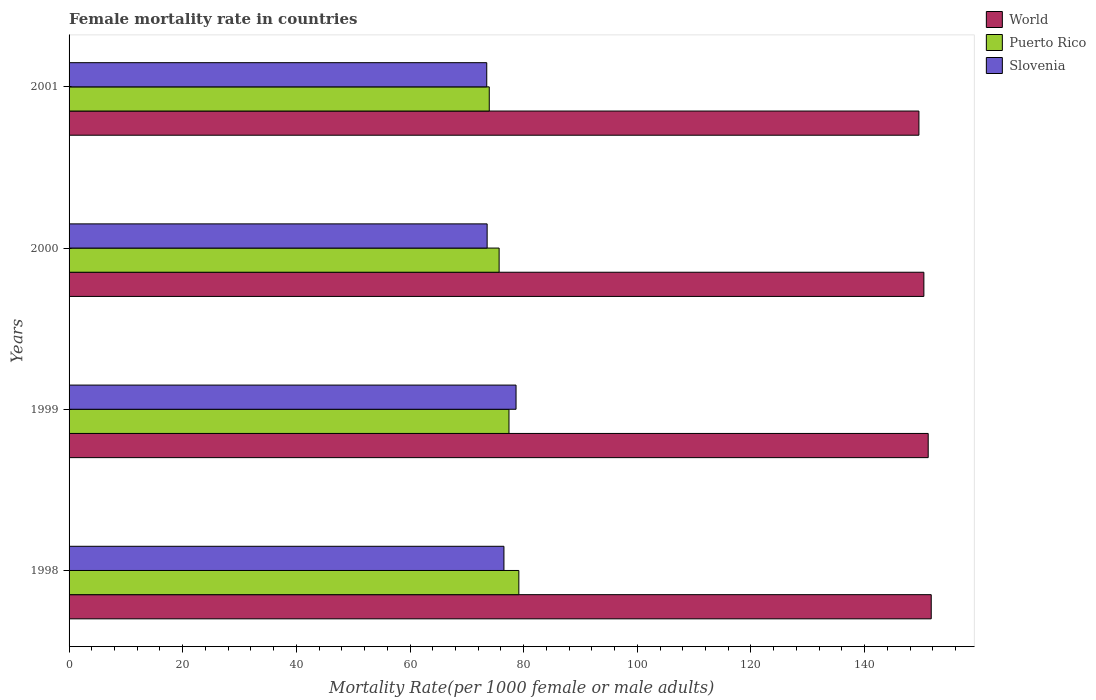How many groups of bars are there?
Your answer should be compact. 4. How many bars are there on the 3rd tick from the bottom?
Your answer should be very brief. 3. In how many cases, is the number of bars for a given year not equal to the number of legend labels?
Give a very brief answer. 0. What is the female mortality rate in World in 2001?
Provide a succinct answer. 149.55. Across all years, what is the maximum female mortality rate in Slovenia?
Offer a very short reply. 78.66. Across all years, what is the minimum female mortality rate in Puerto Rico?
Provide a succinct answer. 73.94. In which year was the female mortality rate in Puerto Rico maximum?
Give a very brief answer. 1998. What is the total female mortality rate in Slovenia in the graph?
Offer a terse response. 302.26. What is the difference between the female mortality rate in Puerto Rico in 1998 and that in 2000?
Ensure brevity in your answer.  3.47. What is the difference between the female mortality rate in Puerto Rico in 2000 and the female mortality rate in Slovenia in 1999?
Offer a very short reply. -2.98. What is the average female mortality rate in Slovenia per year?
Provide a succinct answer. 75.56. In the year 1998, what is the difference between the female mortality rate in Puerto Rico and female mortality rate in World?
Make the answer very short. -72.57. In how many years, is the female mortality rate in World greater than 108 ?
Your answer should be compact. 4. What is the ratio of the female mortality rate in Puerto Rico in 2000 to that in 2001?
Make the answer very short. 1.02. Is the female mortality rate in Puerto Rico in 1998 less than that in 2000?
Keep it short and to the point. No. What is the difference between the highest and the second highest female mortality rate in World?
Keep it short and to the point. 0.53. What is the difference between the highest and the lowest female mortality rate in World?
Provide a succinct answer. 2.17. Is the sum of the female mortality rate in Slovenia in 1998 and 2001 greater than the maximum female mortality rate in World across all years?
Keep it short and to the point. No. What does the 3rd bar from the top in 2000 represents?
Your answer should be compact. World. What does the 1st bar from the bottom in 2000 represents?
Offer a terse response. World. Is it the case that in every year, the sum of the female mortality rate in Puerto Rico and female mortality rate in World is greater than the female mortality rate in Slovenia?
Give a very brief answer. Yes. How many bars are there?
Provide a succinct answer. 12. Are all the bars in the graph horizontal?
Provide a succinct answer. Yes. What is the difference between two consecutive major ticks on the X-axis?
Make the answer very short. 20. Are the values on the major ticks of X-axis written in scientific E-notation?
Offer a very short reply. No. How many legend labels are there?
Provide a short and direct response. 3. What is the title of the graph?
Your answer should be very brief. Female mortality rate in countries. Does "El Salvador" appear as one of the legend labels in the graph?
Offer a very short reply. No. What is the label or title of the X-axis?
Provide a short and direct response. Mortality Rate(per 1000 female or male adults). What is the label or title of the Y-axis?
Make the answer very short. Years. What is the Mortality Rate(per 1000 female or male adults) in World in 1998?
Offer a very short reply. 151.72. What is the Mortality Rate(per 1000 female or male adults) of Puerto Rico in 1998?
Your answer should be very brief. 79.15. What is the Mortality Rate(per 1000 female or male adults) in Slovenia in 1998?
Provide a succinct answer. 76.53. What is the Mortality Rate(per 1000 female or male adults) in World in 1999?
Your answer should be compact. 151.19. What is the Mortality Rate(per 1000 female or male adults) in Puerto Rico in 1999?
Your answer should be very brief. 77.42. What is the Mortality Rate(per 1000 female or male adults) of Slovenia in 1999?
Provide a short and direct response. 78.66. What is the Mortality Rate(per 1000 female or male adults) of World in 2000?
Give a very brief answer. 150.43. What is the Mortality Rate(per 1000 female or male adults) of Puerto Rico in 2000?
Make the answer very short. 75.68. What is the Mortality Rate(per 1000 female or male adults) of Slovenia in 2000?
Provide a short and direct response. 73.57. What is the Mortality Rate(per 1000 female or male adults) in World in 2001?
Provide a succinct answer. 149.55. What is the Mortality Rate(per 1000 female or male adults) of Puerto Rico in 2001?
Ensure brevity in your answer.  73.94. What is the Mortality Rate(per 1000 female or male adults) in Slovenia in 2001?
Offer a terse response. 73.5. Across all years, what is the maximum Mortality Rate(per 1000 female or male adults) of World?
Your response must be concise. 151.72. Across all years, what is the maximum Mortality Rate(per 1000 female or male adults) in Puerto Rico?
Offer a very short reply. 79.15. Across all years, what is the maximum Mortality Rate(per 1000 female or male adults) in Slovenia?
Keep it short and to the point. 78.66. Across all years, what is the minimum Mortality Rate(per 1000 female or male adults) in World?
Your answer should be compact. 149.55. Across all years, what is the minimum Mortality Rate(per 1000 female or male adults) of Puerto Rico?
Ensure brevity in your answer.  73.94. Across all years, what is the minimum Mortality Rate(per 1000 female or male adults) of Slovenia?
Provide a succinct answer. 73.5. What is the total Mortality Rate(per 1000 female or male adults) in World in the graph?
Offer a terse response. 602.89. What is the total Mortality Rate(per 1000 female or male adults) of Puerto Rico in the graph?
Give a very brief answer. 306.19. What is the total Mortality Rate(per 1000 female or male adults) of Slovenia in the graph?
Provide a succinct answer. 302.26. What is the difference between the Mortality Rate(per 1000 female or male adults) in World in 1998 and that in 1999?
Provide a short and direct response. 0.53. What is the difference between the Mortality Rate(per 1000 female or male adults) in Puerto Rico in 1998 and that in 1999?
Provide a succinct answer. 1.74. What is the difference between the Mortality Rate(per 1000 female or male adults) in Slovenia in 1998 and that in 1999?
Your answer should be compact. -2.13. What is the difference between the Mortality Rate(per 1000 female or male adults) of World in 1998 and that in 2000?
Keep it short and to the point. 1.29. What is the difference between the Mortality Rate(per 1000 female or male adults) of Puerto Rico in 1998 and that in 2000?
Your answer should be compact. 3.47. What is the difference between the Mortality Rate(per 1000 female or male adults) in Slovenia in 1998 and that in 2000?
Keep it short and to the point. 2.96. What is the difference between the Mortality Rate(per 1000 female or male adults) in World in 1998 and that in 2001?
Provide a succinct answer. 2.17. What is the difference between the Mortality Rate(per 1000 female or male adults) in Puerto Rico in 1998 and that in 2001?
Make the answer very short. 5.21. What is the difference between the Mortality Rate(per 1000 female or male adults) of Slovenia in 1998 and that in 2001?
Offer a terse response. 3.02. What is the difference between the Mortality Rate(per 1000 female or male adults) of World in 1999 and that in 2000?
Your answer should be very brief. 0.76. What is the difference between the Mortality Rate(per 1000 female or male adults) of Puerto Rico in 1999 and that in 2000?
Make the answer very short. 1.74. What is the difference between the Mortality Rate(per 1000 female or male adults) of Slovenia in 1999 and that in 2000?
Ensure brevity in your answer.  5.09. What is the difference between the Mortality Rate(per 1000 female or male adults) of World in 1999 and that in 2001?
Offer a terse response. 1.63. What is the difference between the Mortality Rate(per 1000 female or male adults) of Puerto Rico in 1999 and that in 2001?
Give a very brief answer. 3.47. What is the difference between the Mortality Rate(per 1000 female or male adults) in Slovenia in 1999 and that in 2001?
Keep it short and to the point. 5.16. What is the difference between the Mortality Rate(per 1000 female or male adults) in World in 2000 and that in 2001?
Keep it short and to the point. 0.87. What is the difference between the Mortality Rate(per 1000 female or male adults) of Puerto Rico in 2000 and that in 2001?
Offer a terse response. 1.74. What is the difference between the Mortality Rate(per 1000 female or male adults) in Slovenia in 2000 and that in 2001?
Give a very brief answer. 0.07. What is the difference between the Mortality Rate(per 1000 female or male adults) of World in 1998 and the Mortality Rate(per 1000 female or male adults) of Puerto Rico in 1999?
Provide a short and direct response. 74.31. What is the difference between the Mortality Rate(per 1000 female or male adults) in World in 1998 and the Mortality Rate(per 1000 female or male adults) in Slovenia in 1999?
Your response must be concise. 73.06. What is the difference between the Mortality Rate(per 1000 female or male adults) of Puerto Rico in 1998 and the Mortality Rate(per 1000 female or male adults) of Slovenia in 1999?
Your answer should be compact. 0.49. What is the difference between the Mortality Rate(per 1000 female or male adults) of World in 1998 and the Mortality Rate(per 1000 female or male adults) of Puerto Rico in 2000?
Keep it short and to the point. 76.04. What is the difference between the Mortality Rate(per 1000 female or male adults) of World in 1998 and the Mortality Rate(per 1000 female or male adults) of Slovenia in 2000?
Provide a succinct answer. 78.15. What is the difference between the Mortality Rate(per 1000 female or male adults) of Puerto Rico in 1998 and the Mortality Rate(per 1000 female or male adults) of Slovenia in 2000?
Keep it short and to the point. 5.58. What is the difference between the Mortality Rate(per 1000 female or male adults) of World in 1998 and the Mortality Rate(per 1000 female or male adults) of Puerto Rico in 2001?
Provide a succinct answer. 77.78. What is the difference between the Mortality Rate(per 1000 female or male adults) in World in 1998 and the Mortality Rate(per 1000 female or male adults) in Slovenia in 2001?
Give a very brief answer. 78.22. What is the difference between the Mortality Rate(per 1000 female or male adults) in Puerto Rico in 1998 and the Mortality Rate(per 1000 female or male adults) in Slovenia in 2001?
Give a very brief answer. 5.65. What is the difference between the Mortality Rate(per 1000 female or male adults) of World in 1999 and the Mortality Rate(per 1000 female or male adults) of Puerto Rico in 2000?
Provide a succinct answer. 75.51. What is the difference between the Mortality Rate(per 1000 female or male adults) of World in 1999 and the Mortality Rate(per 1000 female or male adults) of Slovenia in 2000?
Offer a very short reply. 77.62. What is the difference between the Mortality Rate(per 1000 female or male adults) of Puerto Rico in 1999 and the Mortality Rate(per 1000 female or male adults) of Slovenia in 2000?
Offer a terse response. 3.84. What is the difference between the Mortality Rate(per 1000 female or male adults) in World in 1999 and the Mortality Rate(per 1000 female or male adults) in Puerto Rico in 2001?
Offer a very short reply. 77.24. What is the difference between the Mortality Rate(per 1000 female or male adults) in World in 1999 and the Mortality Rate(per 1000 female or male adults) in Slovenia in 2001?
Your answer should be very brief. 77.69. What is the difference between the Mortality Rate(per 1000 female or male adults) of Puerto Rico in 1999 and the Mortality Rate(per 1000 female or male adults) of Slovenia in 2001?
Your answer should be very brief. 3.91. What is the difference between the Mortality Rate(per 1000 female or male adults) in World in 2000 and the Mortality Rate(per 1000 female or male adults) in Puerto Rico in 2001?
Keep it short and to the point. 76.48. What is the difference between the Mortality Rate(per 1000 female or male adults) of World in 2000 and the Mortality Rate(per 1000 female or male adults) of Slovenia in 2001?
Make the answer very short. 76.92. What is the difference between the Mortality Rate(per 1000 female or male adults) in Puerto Rico in 2000 and the Mortality Rate(per 1000 female or male adults) in Slovenia in 2001?
Make the answer very short. 2.18. What is the average Mortality Rate(per 1000 female or male adults) in World per year?
Keep it short and to the point. 150.72. What is the average Mortality Rate(per 1000 female or male adults) of Puerto Rico per year?
Give a very brief answer. 76.55. What is the average Mortality Rate(per 1000 female or male adults) in Slovenia per year?
Make the answer very short. 75.56. In the year 1998, what is the difference between the Mortality Rate(per 1000 female or male adults) in World and Mortality Rate(per 1000 female or male adults) in Puerto Rico?
Your answer should be compact. 72.57. In the year 1998, what is the difference between the Mortality Rate(per 1000 female or male adults) of World and Mortality Rate(per 1000 female or male adults) of Slovenia?
Give a very brief answer. 75.19. In the year 1998, what is the difference between the Mortality Rate(per 1000 female or male adults) in Puerto Rico and Mortality Rate(per 1000 female or male adults) in Slovenia?
Give a very brief answer. 2.62. In the year 1999, what is the difference between the Mortality Rate(per 1000 female or male adults) of World and Mortality Rate(per 1000 female or male adults) of Puerto Rico?
Ensure brevity in your answer.  73.77. In the year 1999, what is the difference between the Mortality Rate(per 1000 female or male adults) of World and Mortality Rate(per 1000 female or male adults) of Slovenia?
Offer a very short reply. 72.53. In the year 1999, what is the difference between the Mortality Rate(per 1000 female or male adults) in Puerto Rico and Mortality Rate(per 1000 female or male adults) in Slovenia?
Provide a short and direct response. -1.24. In the year 2000, what is the difference between the Mortality Rate(per 1000 female or male adults) of World and Mortality Rate(per 1000 female or male adults) of Puerto Rico?
Make the answer very short. 74.75. In the year 2000, what is the difference between the Mortality Rate(per 1000 female or male adults) of World and Mortality Rate(per 1000 female or male adults) of Slovenia?
Provide a short and direct response. 76.85. In the year 2000, what is the difference between the Mortality Rate(per 1000 female or male adults) in Puerto Rico and Mortality Rate(per 1000 female or male adults) in Slovenia?
Your answer should be compact. 2.11. In the year 2001, what is the difference between the Mortality Rate(per 1000 female or male adults) in World and Mortality Rate(per 1000 female or male adults) in Puerto Rico?
Provide a succinct answer. 75.61. In the year 2001, what is the difference between the Mortality Rate(per 1000 female or male adults) of World and Mortality Rate(per 1000 female or male adults) of Slovenia?
Offer a very short reply. 76.05. In the year 2001, what is the difference between the Mortality Rate(per 1000 female or male adults) of Puerto Rico and Mortality Rate(per 1000 female or male adults) of Slovenia?
Ensure brevity in your answer.  0.44. What is the ratio of the Mortality Rate(per 1000 female or male adults) in World in 1998 to that in 1999?
Offer a terse response. 1. What is the ratio of the Mortality Rate(per 1000 female or male adults) in Puerto Rico in 1998 to that in 1999?
Your answer should be compact. 1.02. What is the ratio of the Mortality Rate(per 1000 female or male adults) of Slovenia in 1998 to that in 1999?
Give a very brief answer. 0.97. What is the ratio of the Mortality Rate(per 1000 female or male adults) in World in 1998 to that in 2000?
Offer a terse response. 1.01. What is the ratio of the Mortality Rate(per 1000 female or male adults) in Puerto Rico in 1998 to that in 2000?
Ensure brevity in your answer.  1.05. What is the ratio of the Mortality Rate(per 1000 female or male adults) of Slovenia in 1998 to that in 2000?
Provide a short and direct response. 1.04. What is the ratio of the Mortality Rate(per 1000 female or male adults) in World in 1998 to that in 2001?
Provide a short and direct response. 1.01. What is the ratio of the Mortality Rate(per 1000 female or male adults) of Puerto Rico in 1998 to that in 2001?
Your response must be concise. 1.07. What is the ratio of the Mortality Rate(per 1000 female or male adults) of Slovenia in 1998 to that in 2001?
Give a very brief answer. 1.04. What is the ratio of the Mortality Rate(per 1000 female or male adults) in World in 1999 to that in 2000?
Keep it short and to the point. 1.01. What is the ratio of the Mortality Rate(per 1000 female or male adults) in Puerto Rico in 1999 to that in 2000?
Your answer should be very brief. 1.02. What is the ratio of the Mortality Rate(per 1000 female or male adults) in Slovenia in 1999 to that in 2000?
Your response must be concise. 1.07. What is the ratio of the Mortality Rate(per 1000 female or male adults) of World in 1999 to that in 2001?
Provide a succinct answer. 1.01. What is the ratio of the Mortality Rate(per 1000 female or male adults) in Puerto Rico in 1999 to that in 2001?
Your answer should be compact. 1.05. What is the ratio of the Mortality Rate(per 1000 female or male adults) of Slovenia in 1999 to that in 2001?
Offer a very short reply. 1.07. What is the ratio of the Mortality Rate(per 1000 female or male adults) in World in 2000 to that in 2001?
Offer a terse response. 1.01. What is the ratio of the Mortality Rate(per 1000 female or male adults) in Puerto Rico in 2000 to that in 2001?
Make the answer very short. 1.02. What is the difference between the highest and the second highest Mortality Rate(per 1000 female or male adults) in World?
Offer a very short reply. 0.53. What is the difference between the highest and the second highest Mortality Rate(per 1000 female or male adults) of Puerto Rico?
Provide a short and direct response. 1.74. What is the difference between the highest and the second highest Mortality Rate(per 1000 female or male adults) in Slovenia?
Provide a short and direct response. 2.13. What is the difference between the highest and the lowest Mortality Rate(per 1000 female or male adults) of World?
Keep it short and to the point. 2.17. What is the difference between the highest and the lowest Mortality Rate(per 1000 female or male adults) in Puerto Rico?
Make the answer very short. 5.21. What is the difference between the highest and the lowest Mortality Rate(per 1000 female or male adults) of Slovenia?
Your response must be concise. 5.16. 